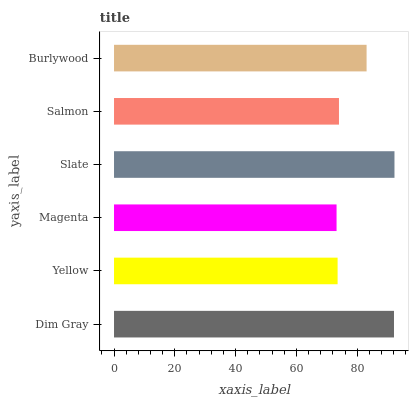Is Magenta the minimum?
Answer yes or no. Yes. Is Slate the maximum?
Answer yes or no. Yes. Is Yellow the minimum?
Answer yes or no. No. Is Yellow the maximum?
Answer yes or no. No. Is Dim Gray greater than Yellow?
Answer yes or no. Yes. Is Yellow less than Dim Gray?
Answer yes or no. Yes. Is Yellow greater than Dim Gray?
Answer yes or no. No. Is Dim Gray less than Yellow?
Answer yes or no. No. Is Burlywood the high median?
Answer yes or no. Yes. Is Salmon the low median?
Answer yes or no. Yes. Is Slate the high median?
Answer yes or no. No. Is Burlywood the low median?
Answer yes or no. No. 